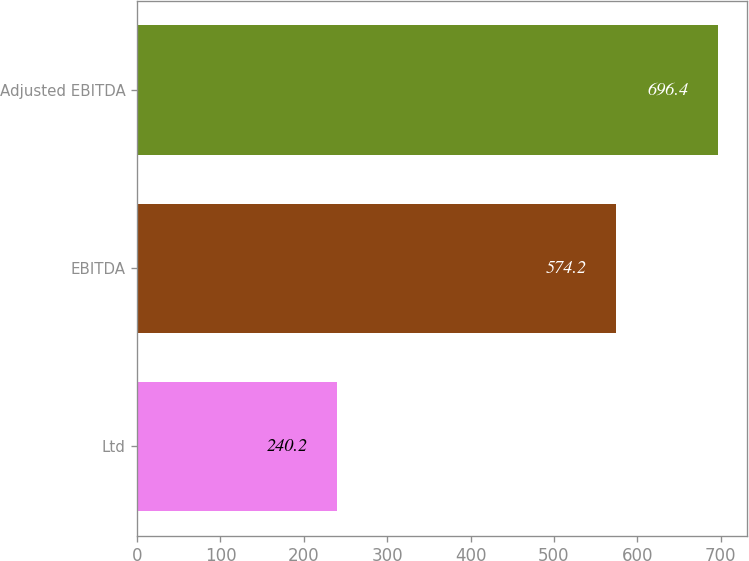Convert chart. <chart><loc_0><loc_0><loc_500><loc_500><bar_chart><fcel>Ltd<fcel>EBITDA<fcel>Adjusted EBITDA<nl><fcel>240.2<fcel>574.2<fcel>696.4<nl></chart> 